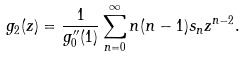Convert formula to latex. <formula><loc_0><loc_0><loc_500><loc_500>g _ { 2 } ( z ) = \frac { 1 } { g _ { 0 } ^ { \prime \prime } ( 1 ) } \sum _ { n = 0 } ^ { \infty } n ( n - 1 ) s _ { n } z ^ { n - 2 } .</formula> 